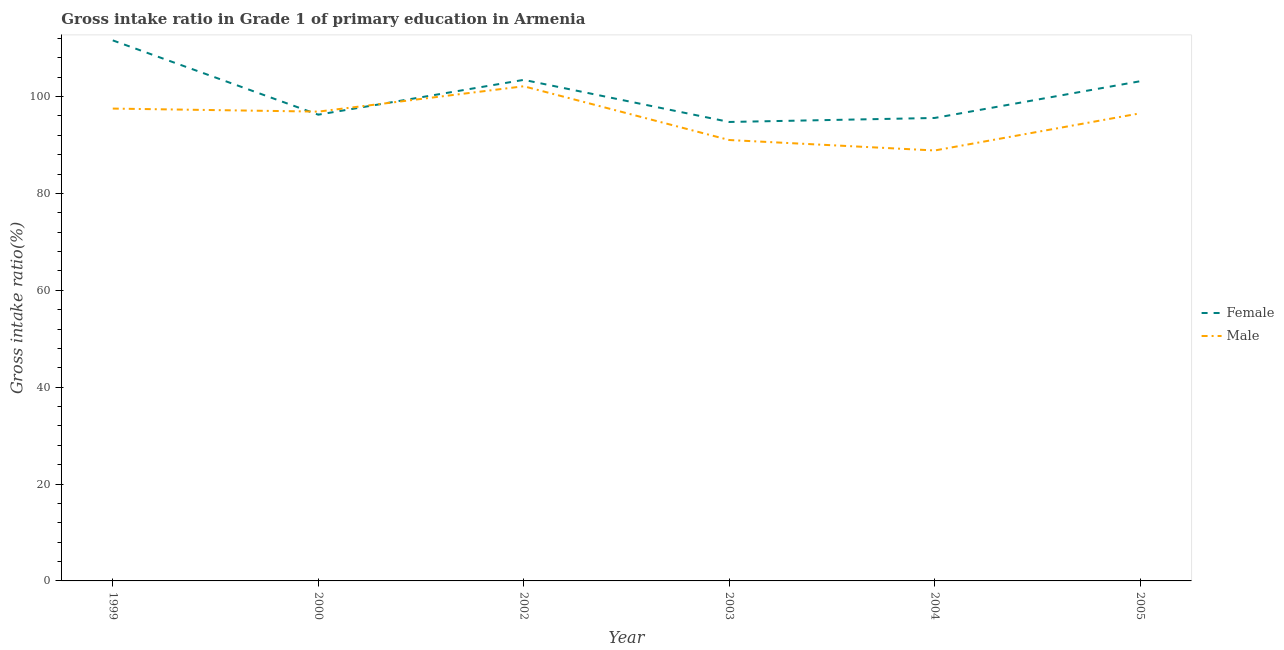Does the line corresponding to gross intake ratio(female) intersect with the line corresponding to gross intake ratio(male)?
Offer a very short reply. Yes. Is the number of lines equal to the number of legend labels?
Offer a terse response. Yes. What is the gross intake ratio(female) in 1999?
Make the answer very short. 111.59. Across all years, what is the maximum gross intake ratio(male)?
Keep it short and to the point. 102.12. Across all years, what is the minimum gross intake ratio(female)?
Provide a succinct answer. 94.75. What is the total gross intake ratio(female) in the graph?
Your answer should be very brief. 604.78. What is the difference between the gross intake ratio(male) in 2000 and that in 2003?
Offer a very short reply. 5.86. What is the difference between the gross intake ratio(female) in 2002 and the gross intake ratio(male) in 2000?
Provide a short and direct response. 6.56. What is the average gross intake ratio(male) per year?
Provide a succinct answer. 95.49. In the year 2002, what is the difference between the gross intake ratio(female) and gross intake ratio(male)?
Provide a succinct answer. 1.32. What is the ratio of the gross intake ratio(male) in 2002 to that in 2003?
Offer a terse response. 1.12. Is the difference between the gross intake ratio(female) in 2004 and 2005 greater than the difference between the gross intake ratio(male) in 2004 and 2005?
Offer a very short reply. Yes. What is the difference between the highest and the second highest gross intake ratio(female)?
Your response must be concise. 8.15. What is the difference between the highest and the lowest gross intake ratio(female)?
Give a very brief answer. 16.84. In how many years, is the gross intake ratio(female) greater than the average gross intake ratio(female) taken over all years?
Your answer should be compact. 3. Does the gross intake ratio(female) monotonically increase over the years?
Your response must be concise. No. Are the values on the major ticks of Y-axis written in scientific E-notation?
Keep it short and to the point. No. How many legend labels are there?
Your answer should be very brief. 2. How are the legend labels stacked?
Provide a short and direct response. Vertical. What is the title of the graph?
Offer a very short reply. Gross intake ratio in Grade 1 of primary education in Armenia. What is the label or title of the X-axis?
Ensure brevity in your answer.  Year. What is the label or title of the Y-axis?
Your answer should be compact. Gross intake ratio(%). What is the Gross intake ratio(%) of Female in 1999?
Ensure brevity in your answer.  111.59. What is the Gross intake ratio(%) in Male in 1999?
Offer a terse response. 97.51. What is the Gross intake ratio(%) in Female in 2000?
Your answer should be compact. 96.25. What is the Gross intake ratio(%) in Male in 2000?
Make the answer very short. 96.89. What is the Gross intake ratio(%) in Female in 2002?
Keep it short and to the point. 103.44. What is the Gross intake ratio(%) of Male in 2002?
Keep it short and to the point. 102.12. What is the Gross intake ratio(%) of Female in 2003?
Keep it short and to the point. 94.75. What is the Gross intake ratio(%) in Male in 2003?
Keep it short and to the point. 91.02. What is the Gross intake ratio(%) in Female in 2004?
Keep it short and to the point. 95.58. What is the Gross intake ratio(%) in Male in 2004?
Offer a very short reply. 88.86. What is the Gross intake ratio(%) of Female in 2005?
Your answer should be very brief. 103.16. What is the Gross intake ratio(%) in Male in 2005?
Offer a terse response. 96.54. Across all years, what is the maximum Gross intake ratio(%) in Female?
Ensure brevity in your answer.  111.59. Across all years, what is the maximum Gross intake ratio(%) of Male?
Your answer should be compact. 102.12. Across all years, what is the minimum Gross intake ratio(%) of Female?
Keep it short and to the point. 94.75. Across all years, what is the minimum Gross intake ratio(%) in Male?
Offer a very short reply. 88.86. What is the total Gross intake ratio(%) of Female in the graph?
Give a very brief answer. 604.78. What is the total Gross intake ratio(%) of Male in the graph?
Offer a very short reply. 572.95. What is the difference between the Gross intake ratio(%) of Female in 1999 and that in 2000?
Give a very brief answer. 15.34. What is the difference between the Gross intake ratio(%) of Male in 1999 and that in 2000?
Ensure brevity in your answer.  0.63. What is the difference between the Gross intake ratio(%) in Female in 1999 and that in 2002?
Provide a succinct answer. 8.15. What is the difference between the Gross intake ratio(%) of Male in 1999 and that in 2002?
Ensure brevity in your answer.  -4.61. What is the difference between the Gross intake ratio(%) of Female in 1999 and that in 2003?
Make the answer very short. 16.84. What is the difference between the Gross intake ratio(%) in Male in 1999 and that in 2003?
Offer a very short reply. 6.49. What is the difference between the Gross intake ratio(%) of Female in 1999 and that in 2004?
Make the answer very short. 16.02. What is the difference between the Gross intake ratio(%) in Male in 1999 and that in 2004?
Your response must be concise. 8.65. What is the difference between the Gross intake ratio(%) of Female in 1999 and that in 2005?
Keep it short and to the point. 8.43. What is the difference between the Gross intake ratio(%) in Male in 1999 and that in 2005?
Make the answer very short. 0.97. What is the difference between the Gross intake ratio(%) in Female in 2000 and that in 2002?
Give a very brief answer. -7.19. What is the difference between the Gross intake ratio(%) in Male in 2000 and that in 2002?
Make the answer very short. -5.24. What is the difference between the Gross intake ratio(%) of Female in 2000 and that in 2003?
Your answer should be very brief. 1.5. What is the difference between the Gross intake ratio(%) in Male in 2000 and that in 2003?
Make the answer very short. 5.86. What is the difference between the Gross intake ratio(%) in Female in 2000 and that in 2004?
Provide a short and direct response. 0.68. What is the difference between the Gross intake ratio(%) of Male in 2000 and that in 2004?
Provide a succinct answer. 8.02. What is the difference between the Gross intake ratio(%) in Female in 2000 and that in 2005?
Provide a short and direct response. -6.91. What is the difference between the Gross intake ratio(%) of Male in 2000 and that in 2005?
Offer a terse response. 0.35. What is the difference between the Gross intake ratio(%) in Female in 2002 and that in 2003?
Provide a succinct answer. 8.69. What is the difference between the Gross intake ratio(%) of Male in 2002 and that in 2003?
Offer a very short reply. 11.1. What is the difference between the Gross intake ratio(%) of Female in 2002 and that in 2004?
Give a very brief answer. 7.86. What is the difference between the Gross intake ratio(%) in Male in 2002 and that in 2004?
Ensure brevity in your answer.  13.26. What is the difference between the Gross intake ratio(%) in Female in 2002 and that in 2005?
Give a very brief answer. 0.28. What is the difference between the Gross intake ratio(%) in Male in 2002 and that in 2005?
Provide a succinct answer. 5.58. What is the difference between the Gross intake ratio(%) of Female in 2003 and that in 2004?
Your answer should be compact. -0.83. What is the difference between the Gross intake ratio(%) of Male in 2003 and that in 2004?
Keep it short and to the point. 2.16. What is the difference between the Gross intake ratio(%) in Female in 2003 and that in 2005?
Provide a succinct answer. -8.41. What is the difference between the Gross intake ratio(%) of Male in 2003 and that in 2005?
Your answer should be compact. -5.52. What is the difference between the Gross intake ratio(%) in Female in 2004 and that in 2005?
Offer a terse response. -7.58. What is the difference between the Gross intake ratio(%) of Male in 2004 and that in 2005?
Offer a terse response. -7.67. What is the difference between the Gross intake ratio(%) in Female in 1999 and the Gross intake ratio(%) in Male in 2000?
Make the answer very short. 14.71. What is the difference between the Gross intake ratio(%) of Female in 1999 and the Gross intake ratio(%) of Male in 2002?
Offer a very short reply. 9.47. What is the difference between the Gross intake ratio(%) in Female in 1999 and the Gross intake ratio(%) in Male in 2003?
Offer a very short reply. 20.57. What is the difference between the Gross intake ratio(%) of Female in 1999 and the Gross intake ratio(%) of Male in 2004?
Offer a very short reply. 22.73. What is the difference between the Gross intake ratio(%) in Female in 1999 and the Gross intake ratio(%) in Male in 2005?
Offer a very short reply. 15.05. What is the difference between the Gross intake ratio(%) of Female in 2000 and the Gross intake ratio(%) of Male in 2002?
Provide a short and direct response. -5.87. What is the difference between the Gross intake ratio(%) of Female in 2000 and the Gross intake ratio(%) of Male in 2003?
Offer a terse response. 5.23. What is the difference between the Gross intake ratio(%) of Female in 2000 and the Gross intake ratio(%) of Male in 2004?
Provide a succinct answer. 7.39. What is the difference between the Gross intake ratio(%) of Female in 2000 and the Gross intake ratio(%) of Male in 2005?
Provide a succinct answer. -0.29. What is the difference between the Gross intake ratio(%) in Female in 2002 and the Gross intake ratio(%) in Male in 2003?
Ensure brevity in your answer.  12.42. What is the difference between the Gross intake ratio(%) of Female in 2002 and the Gross intake ratio(%) of Male in 2004?
Provide a short and direct response. 14.58. What is the difference between the Gross intake ratio(%) of Female in 2002 and the Gross intake ratio(%) of Male in 2005?
Give a very brief answer. 6.9. What is the difference between the Gross intake ratio(%) in Female in 2003 and the Gross intake ratio(%) in Male in 2004?
Your response must be concise. 5.88. What is the difference between the Gross intake ratio(%) of Female in 2003 and the Gross intake ratio(%) of Male in 2005?
Offer a terse response. -1.79. What is the difference between the Gross intake ratio(%) in Female in 2004 and the Gross intake ratio(%) in Male in 2005?
Offer a very short reply. -0.96. What is the average Gross intake ratio(%) of Female per year?
Provide a succinct answer. 100.8. What is the average Gross intake ratio(%) of Male per year?
Offer a very short reply. 95.49. In the year 1999, what is the difference between the Gross intake ratio(%) of Female and Gross intake ratio(%) of Male?
Your response must be concise. 14.08. In the year 2000, what is the difference between the Gross intake ratio(%) of Female and Gross intake ratio(%) of Male?
Provide a short and direct response. -0.63. In the year 2002, what is the difference between the Gross intake ratio(%) in Female and Gross intake ratio(%) in Male?
Offer a very short reply. 1.32. In the year 2003, what is the difference between the Gross intake ratio(%) in Female and Gross intake ratio(%) in Male?
Make the answer very short. 3.73. In the year 2004, what is the difference between the Gross intake ratio(%) in Female and Gross intake ratio(%) in Male?
Ensure brevity in your answer.  6.71. In the year 2005, what is the difference between the Gross intake ratio(%) of Female and Gross intake ratio(%) of Male?
Provide a succinct answer. 6.62. What is the ratio of the Gross intake ratio(%) of Female in 1999 to that in 2000?
Offer a terse response. 1.16. What is the ratio of the Gross intake ratio(%) in Female in 1999 to that in 2002?
Offer a terse response. 1.08. What is the ratio of the Gross intake ratio(%) of Male in 1999 to that in 2002?
Offer a terse response. 0.95. What is the ratio of the Gross intake ratio(%) in Female in 1999 to that in 2003?
Provide a short and direct response. 1.18. What is the ratio of the Gross intake ratio(%) in Male in 1999 to that in 2003?
Keep it short and to the point. 1.07. What is the ratio of the Gross intake ratio(%) in Female in 1999 to that in 2004?
Your answer should be compact. 1.17. What is the ratio of the Gross intake ratio(%) in Male in 1999 to that in 2004?
Your answer should be compact. 1.1. What is the ratio of the Gross intake ratio(%) of Female in 1999 to that in 2005?
Your answer should be very brief. 1.08. What is the ratio of the Gross intake ratio(%) in Male in 1999 to that in 2005?
Ensure brevity in your answer.  1.01. What is the ratio of the Gross intake ratio(%) in Female in 2000 to that in 2002?
Offer a terse response. 0.93. What is the ratio of the Gross intake ratio(%) in Male in 2000 to that in 2002?
Your answer should be compact. 0.95. What is the ratio of the Gross intake ratio(%) in Female in 2000 to that in 2003?
Give a very brief answer. 1.02. What is the ratio of the Gross intake ratio(%) in Male in 2000 to that in 2003?
Provide a succinct answer. 1.06. What is the ratio of the Gross intake ratio(%) in Female in 2000 to that in 2004?
Ensure brevity in your answer.  1.01. What is the ratio of the Gross intake ratio(%) in Male in 2000 to that in 2004?
Offer a very short reply. 1.09. What is the ratio of the Gross intake ratio(%) of Female in 2000 to that in 2005?
Provide a succinct answer. 0.93. What is the ratio of the Gross intake ratio(%) in Male in 2000 to that in 2005?
Give a very brief answer. 1. What is the ratio of the Gross intake ratio(%) of Female in 2002 to that in 2003?
Keep it short and to the point. 1.09. What is the ratio of the Gross intake ratio(%) of Male in 2002 to that in 2003?
Keep it short and to the point. 1.12. What is the ratio of the Gross intake ratio(%) of Female in 2002 to that in 2004?
Give a very brief answer. 1.08. What is the ratio of the Gross intake ratio(%) of Male in 2002 to that in 2004?
Your answer should be very brief. 1.15. What is the ratio of the Gross intake ratio(%) of Female in 2002 to that in 2005?
Your answer should be compact. 1. What is the ratio of the Gross intake ratio(%) of Male in 2002 to that in 2005?
Your response must be concise. 1.06. What is the ratio of the Gross intake ratio(%) in Female in 2003 to that in 2004?
Provide a short and direct response. 0.99. What is the ratio of the Gross intake ratio(%) in Male in 2003 to that in 2004?
Offer a terse response. 1.02. What is the ratio of the Gross intake ratio(%) in Female in 2003 to that in 2005?
Your answer should be very brief. 0.92. What is the ratio of the Gross intake ratio(%) in Male in 2003 to that in 2005?
Give a very brief answer. 0.94. What is the ratio of the Gross intake ratio(%) in Female in 2004 to that in 2005?
Make the answer very short. 0.93. What is the ratio of the Gross intake ratio(%) of Male in 2004 to that in 2005?
Make the answer very short. 0.92. What is the difference between the highest and the second highest Gross intake ratio(%) of Female?
Your answer should be very brief. 8.15. What is the difference between the highest and the second highest Gross intake ratio(%) of Male?
Provide a short and direct response. 4.61. What is the difference between the highest and the lowest Gross intake ratio(%) of Female?
Offer a very short reply. 16.84. What is the difference between the highest and the lowest Gross intake ratio(%) in Male?
Offer a very short reply. 13.26. 